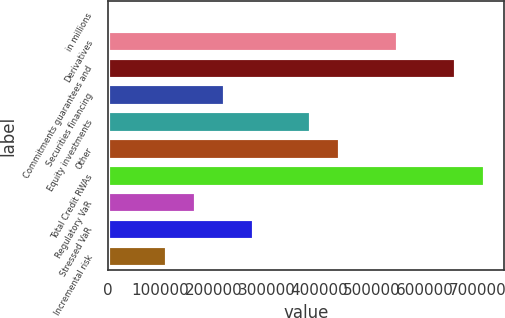Convert chart. <chart><loc_0><loc_0><loc_500><loc_500><bar_chart><fcel>in millions<fcel>Derivatives<fcel>Commitments guarantees and<fcel>Securities financing<fcel>Equity investments<fcel>Other<fcel>Total Credit RWAs<fcel>Regulatory VaR<fcel>Stressed VaR<fcel>Incremental risk<nl><fcel>2016<fcel>549650<fcel>659177<fcel>221070<fcel>385360<fcel>440123<fcel>713940<fcel>166306<fcel>275833<fcel>111543<nl></chart> 